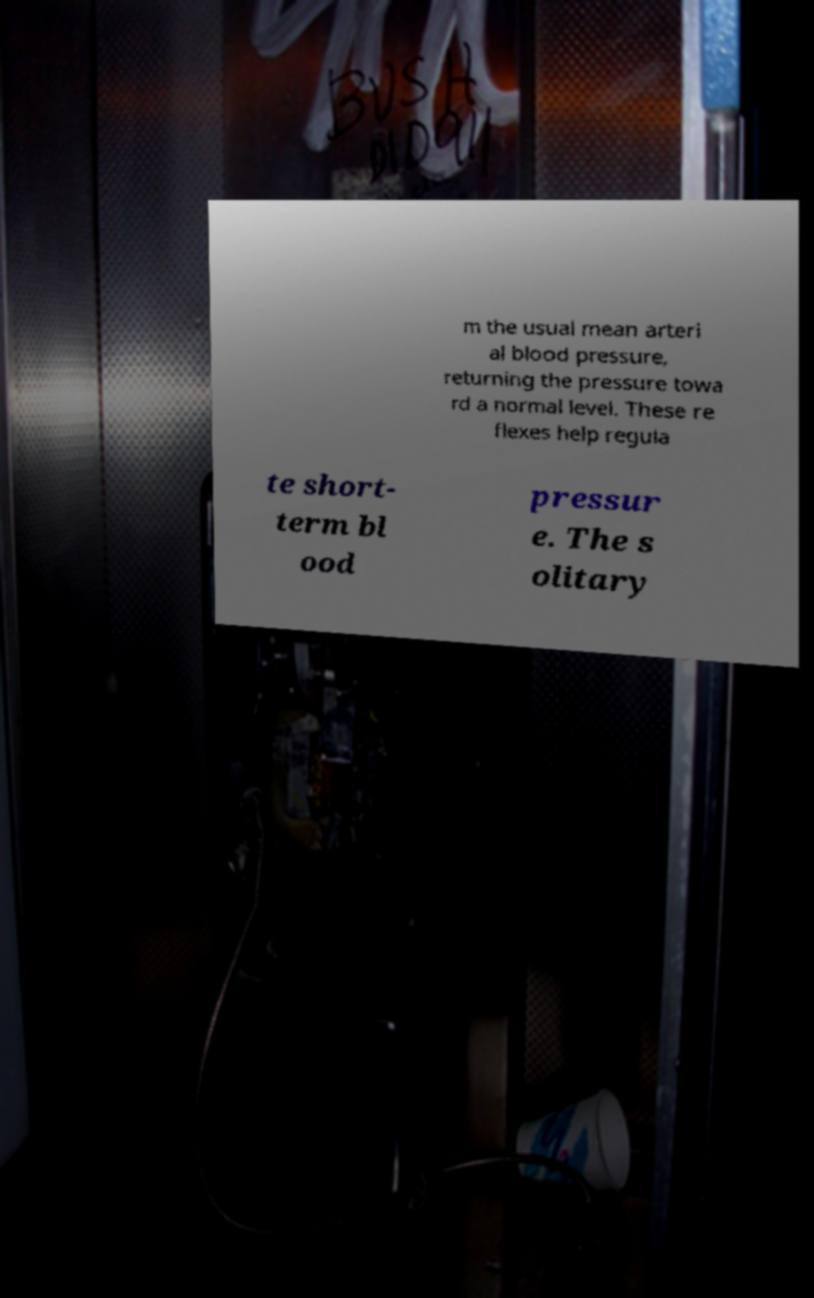For documentation purposes, I need the text within this image transcribed. Could you provide that? m the usual mean arteri al blood pressure, returning the pressure towa rd a normal level. These re flexes help regula te short- term bl ood pressur e. The s olitary 